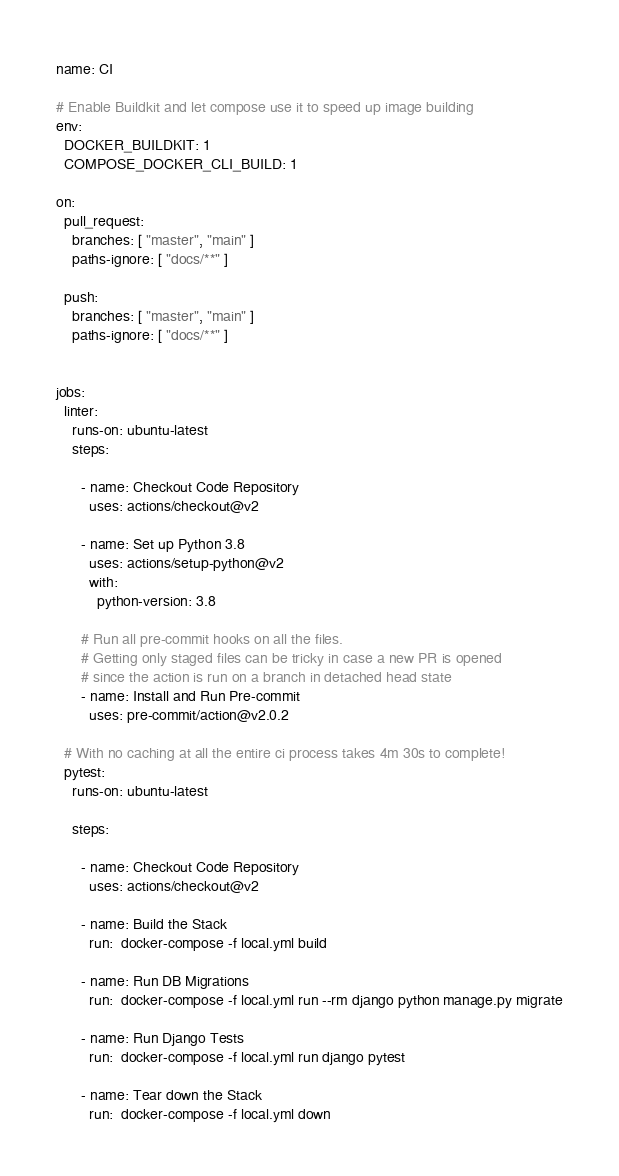Convert code to text. <code><loc_0><loc_0><loc_500><loc_500><_YAML_>name: CI

# Enable Buildkit and let compose use it to speed up image building
env:
  DOCKER_BUILDKIT: 1
  COMPOSE_DOCKER_CLI_BUILD: 1

on:
  pull_request:
    branches: [ "master", "main" ]
    paths-ignore: [ "docs/**" ]

  push:
    branches: [ "master", "main" ]
    paths-ignore: [ "docs/**" ]


jobs:
  linter:
    runs-on: ubuntu-latest
    steps:

      - name: Checkout Code Repository
        uses: actions/checkout@v2

      - name: Set up Python 3.8
        uses: actions/setup-python@v2
        with:
          python-version: 3.8

      # Run all pre-commit hooks on all the files.
      # Getting only staged files can be tricky in case a new PR is opened
      # since the action is run on a branch in detached head state
      - name: Install and Run Pre-commit
        uses: pre-commit/action@v2.0.2

  # With no caching at all the entire ci process takes 4m 30s to complete!
  pytest:
    runs-on: ubuntu-latest

    steps:

      - name: Checkout Code Repository
        uses: actions/checkout@v2

      - name: Build the Stack
        run:  docker-compose -f local.yml build

      - name: Run DB Migrations
        run:  docker-compose -f local.yml run --rm django python manage.py migrate

      - name: Run Django Tests
        run:  docker-compose -f local.yml run django pytest

      - name: Tear down the Stack
        run:  docker-compose -f local.yml down
</code> 